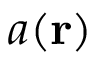Convert formula to latex. <formula><loc_0><loc_0><loc_500><loc_500>a ( r )</formula> 